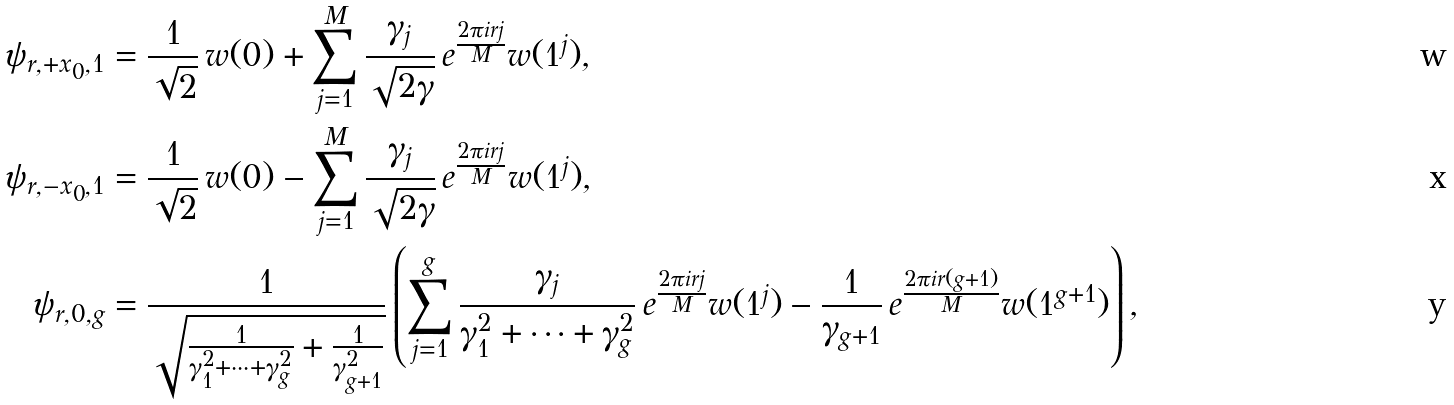<formula> <loc_0><loc_0><loc_500><loc_500>\psi _ { r , + x _ { 0 } , 1 } & = \frac { 1 } { \sqrt { 2 } } \, w ( 0 ) + \sum _ { j = 1 } ^ { M } \frac { \gamma _ { j } } { \sqrt { 2 \gamma } } \, e ^ { \frac { 2 \pi i r j } { M } } w ( 1 ^ { j } ) , \\ \psi _ { r , - x _ { 0 } , 1 } & = \frac { 1 } { \sqrt { 2 } } \, w ( 0 ) - \sum _ { j = 1 } ^ { M } \frac { \gamma _ { j } } { \sqrt { 2 \gamma } } \, e ^ { \frac { 2 \pi i r j } { M } } w ( 1 ^ { j } ) , \\ \psi _ { r , 0 , g } & = \frac { 1 } { \sqrt { \frac { 1 } { \gamma _ { 1 } ^ { 2 } + \cdots + \gamma _ { g } ^ { 2 } } + \frac { 1 } { \gamma _ { g + 1 } ^ { 2 } } } } \left ( \sum _ { j = 1 } ^ { g } \frac { \gamma _ { j } } { \gamma _ { 1 } ^ { 2 } + \cdots + \gamma _ { g } ^ { 2 } } \, e ^ { \frac { 2 \pi i r j } { M } } w ( 1 ^ { j } ) - \frac { 1 } { \gamma _ { g + 1 } } \, e ^ { \frac { 2 \pi i r ( g + 1 ) } { M } } w ( 1 ^ { g + 1 } ) \right ) ,</formula> 